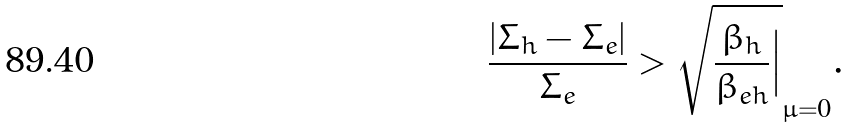<formula> <loc_0><loc_0><loc_500><loc_500>\frac { | \Sigma _ { h } - \Sigma _ { e } | } { \Sigma _ { e } } > \sqrt { \frac { \beta _ { h } } { \beta _ { e h } } \Big | } _ { \mu = 0 } .</formula> 